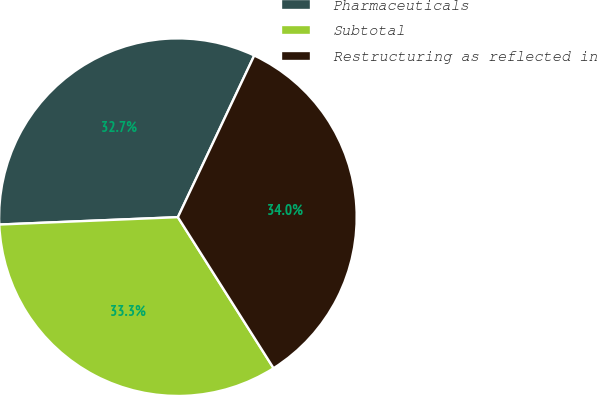<chart> <loc_0><loc_0><loc_500><loc_500><pie_chart><fcel>Pharmaceuticals<fcel>Subtotal<fcel>Restructuring as reflected in<nl><fcel>32.68%<fcel>33.33%<fcel>33.99%<nl></chart> 